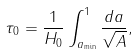Convert formula to latex. <formula><loc_0><loc_0><loc_500><loc_500>\tau _ { 0 } = \frac { 1 } { H _ { 0 } } \int _ { a _ { \min } } ^ { 1 } { \frac { d a } { \sqrt { A } } } ,</formula> 